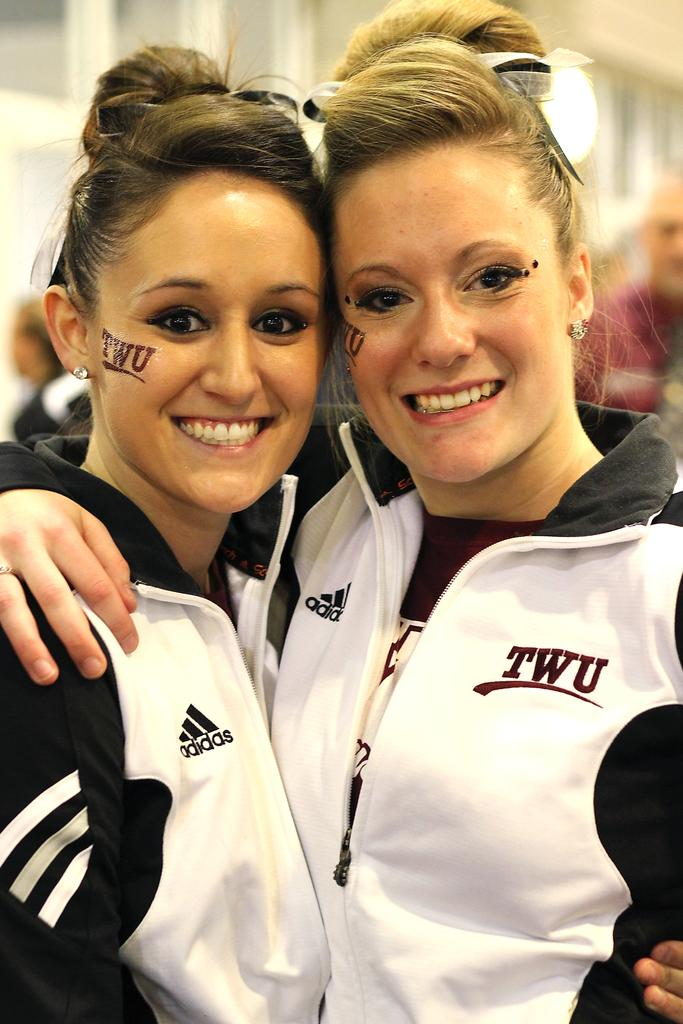<image>
Offer a succinct explanation of the picture presented. Two cheerleaders posing in black and white Adidas sweatshirts. 